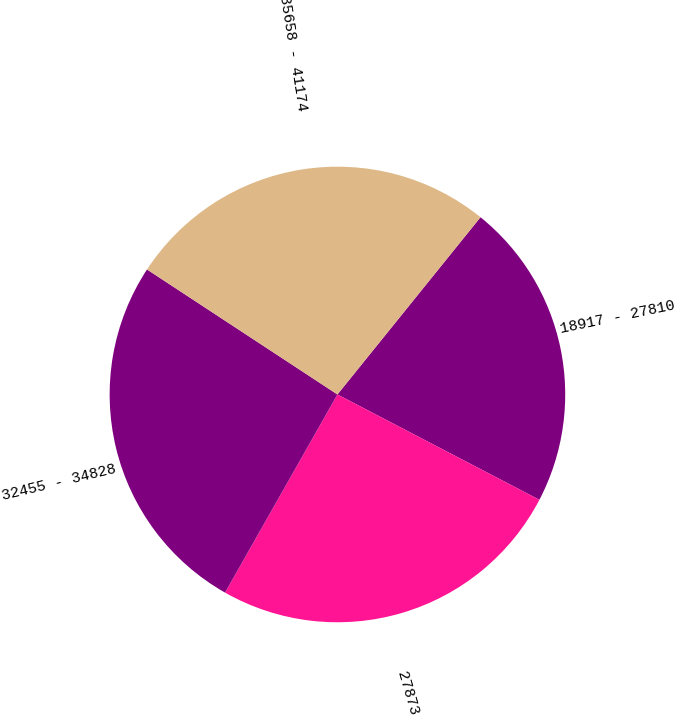<chart> <loc_0><loc_0><loc_500><loc_500><pie_chart><fcel>18917 - 27810<fcel>27873 - 32125<fcel>32455 - 34828<fcel>35658 - 41174<nl><fcel>21.84%<fcel>25.56%<fcel>26.03%<fcel>26.56%<nl></chart> 